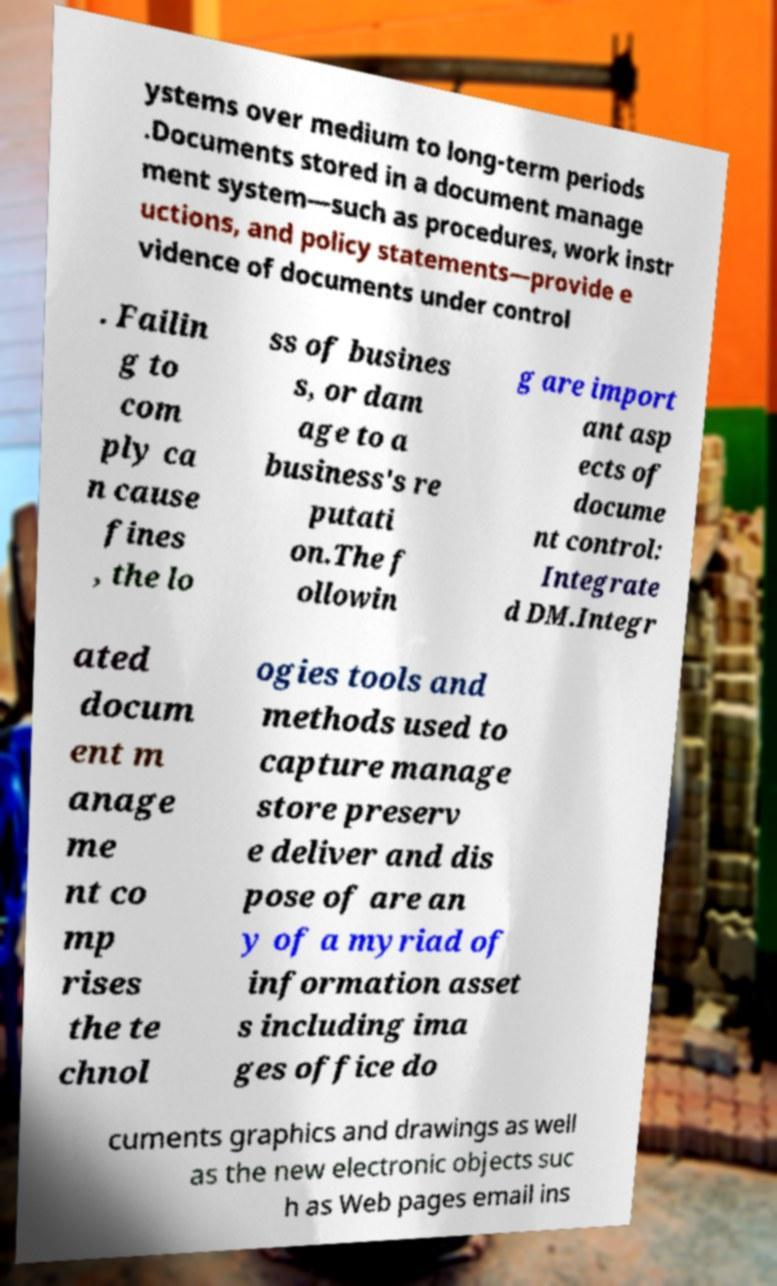For documentation purposes, I need the text within this image transcribed. Could you provide that? ystems over medium to long-term periods .Documents stored in a document manage ment system—such as procedures, work instr uctions, and policy statements—provide e vidence of documents under control . Failin g to com ply ca n cause fines , the lo ss of busines s, or dam age to a business's re putati on.The f ollowin g are import ant asp ects of docume nt control: Integrate d DM.Integr ated docum ent m anage me nt co mp rises the te chnol ogies tools and methods used to capture manage store preserv e deliver and dis pose of are an y of a myriad of information asset s including ima ges office do cuments graphics and drawings as well as the new electronic objects suc h as Web pages email ins 